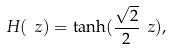Convert formula to latex. <formula><loc_0><loc_0><loc_500><loc_500>H ( \ z ) = \tanh ( \frac { \sqrt { 2 } } { 2 } \ z ) ,</formula> 